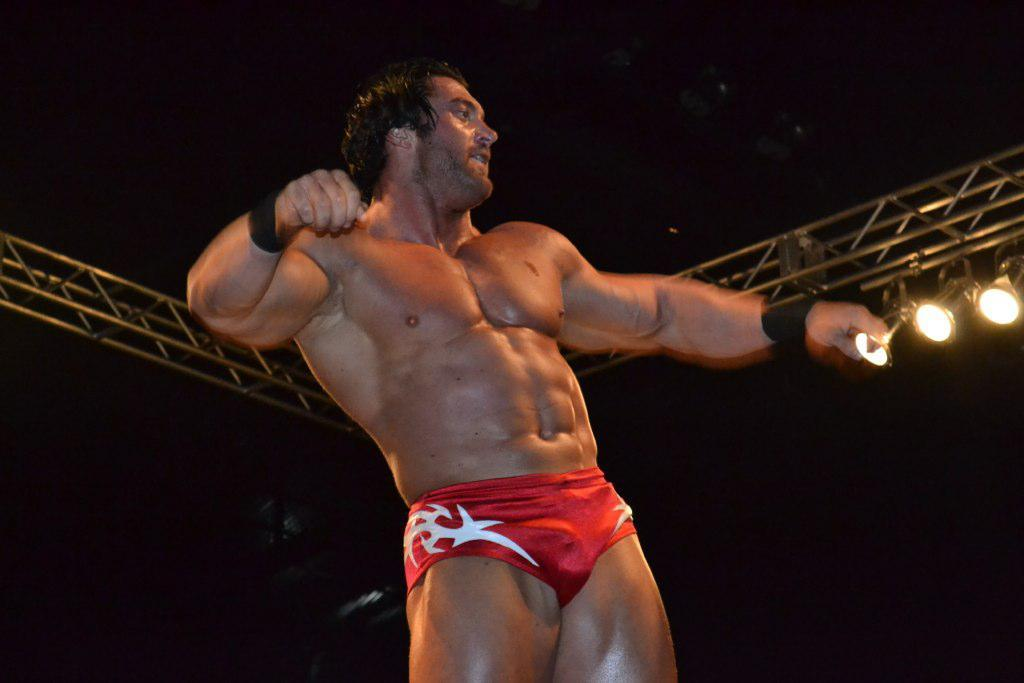What is the person in the image wearing? The person is wearing a red dress. What can be seen in the image besides the person? There are metal rods and many lights in the image. What is the color of the background in the image? The background of the image is black. How many oranges are hanging from the metal rods in the image? There are no oranges present in the image; it only features a person wearing a red dress, metal rods, and many lights against a black background. 